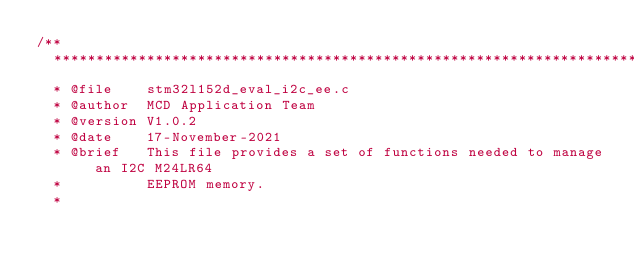Convert code to text. <code><loc_0><loc_0><loc_500><loc_500><_C_>/**
  ******************************************************************************
  * @file    stm32l152d_eval_i2c_ee.c
  * @author  MCD Application Team
  * @version V1.0.2
  * @date    17-November-2021
  * @brief   This file provides a set of functions needed to manage an I2C M24LR64 
  *          EEPROM memory.
  *          </code> 